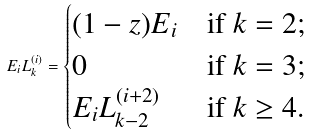<formula> <loc_0><loc_0><loc_500><loc_500>E _ { i } L _ { k } ^ { ( i ) } = \begin{cases} ( 1 - z ) E _ { i } & \text {if $k=2$;} \\ 0 & \text {if $k=3$;} \\ E _ { i } L ^ { ( i + 2 ) } _ { k - 2 } & \text {if $k\geq4$.} \end{cases}</formula> 